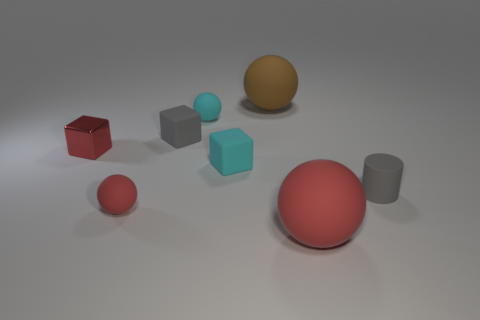Are there any other things that are made of the same material as the tiny red cube?
Provide a short and direct response. No. What is the size of the brown sphere that is the same material as the cylinder?
Give a very brief answer. Large. There is a matte cube left of the tiny cyan cube; is its size the same as the sphere that is right of the big brown rubber object?
Provide a succinct answer. No. What number of things are matte spheres to the right of the large brown rubber sphere or tiny green rubber cylinders?
Your answer should be compact. 1. Are there fewer big yellow shiny objects than small cyan balls?
Make the answer very short. Yes. There is a small red object that is to the right of the small red shiny cube that is behind the red ball that is left of the big brown rubber thing; what shape is it?
Your answer should be compact. Sphere. What shape is the rubber thing that is the same color as the cylinder?
Give a very brief answer. Cube. Is there a brown matte sphere?
Your answer should be compact. Yes. There is a red cube; is its size the same as the matte object on the right side of the big red rubber object?
Provide a short and direct response. Yes. Is there a small red metal cube to the right of the red matte thing on the right side of the small cyan block?
Ensure brevity in your answer.  No. 